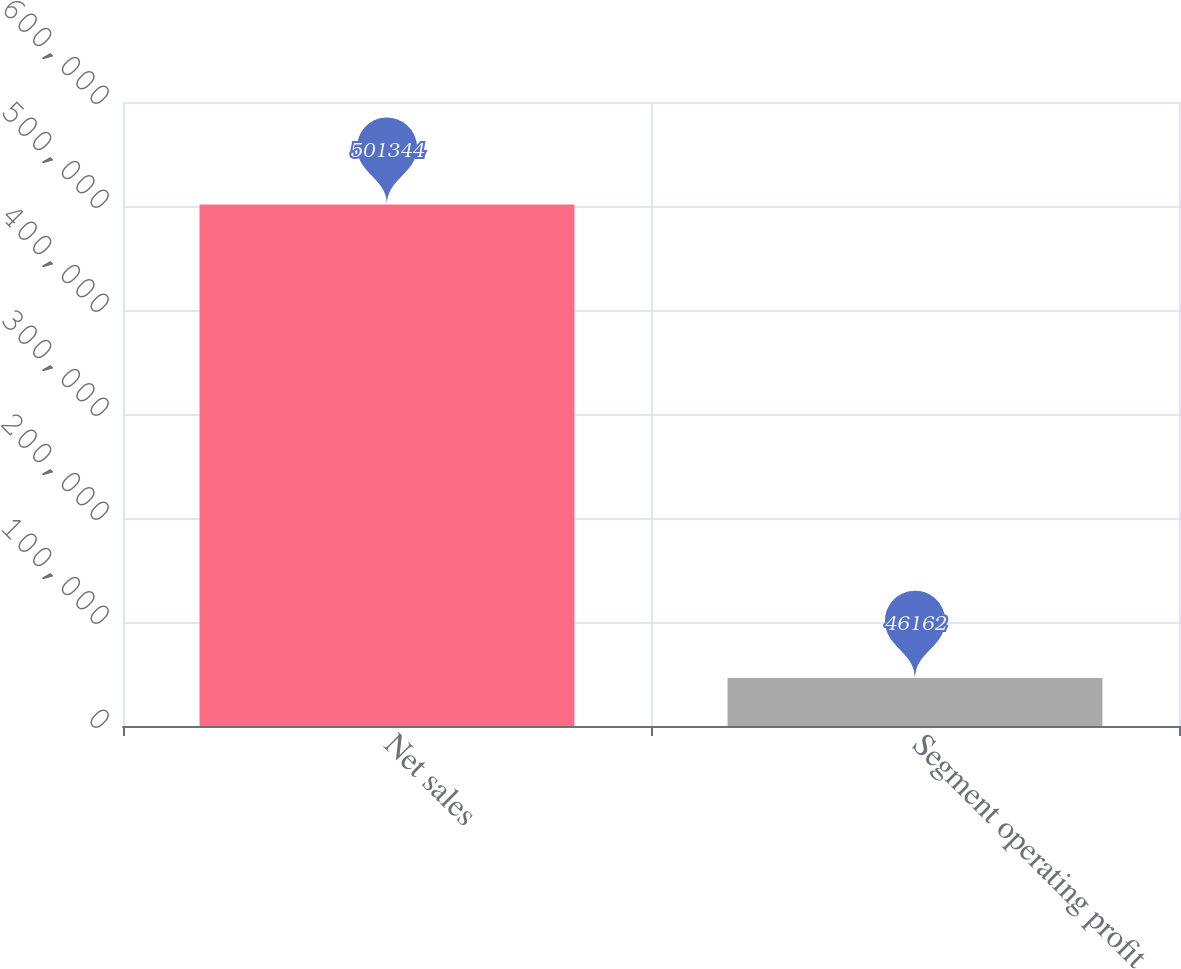Convert chart. <chart><loc_0><loc_0><loc_500><loc_500><bar_chart><fcel>Net sales<fcel>Segment operating profit<nl><fcel>501344<fcel>46162<nl></chart> 